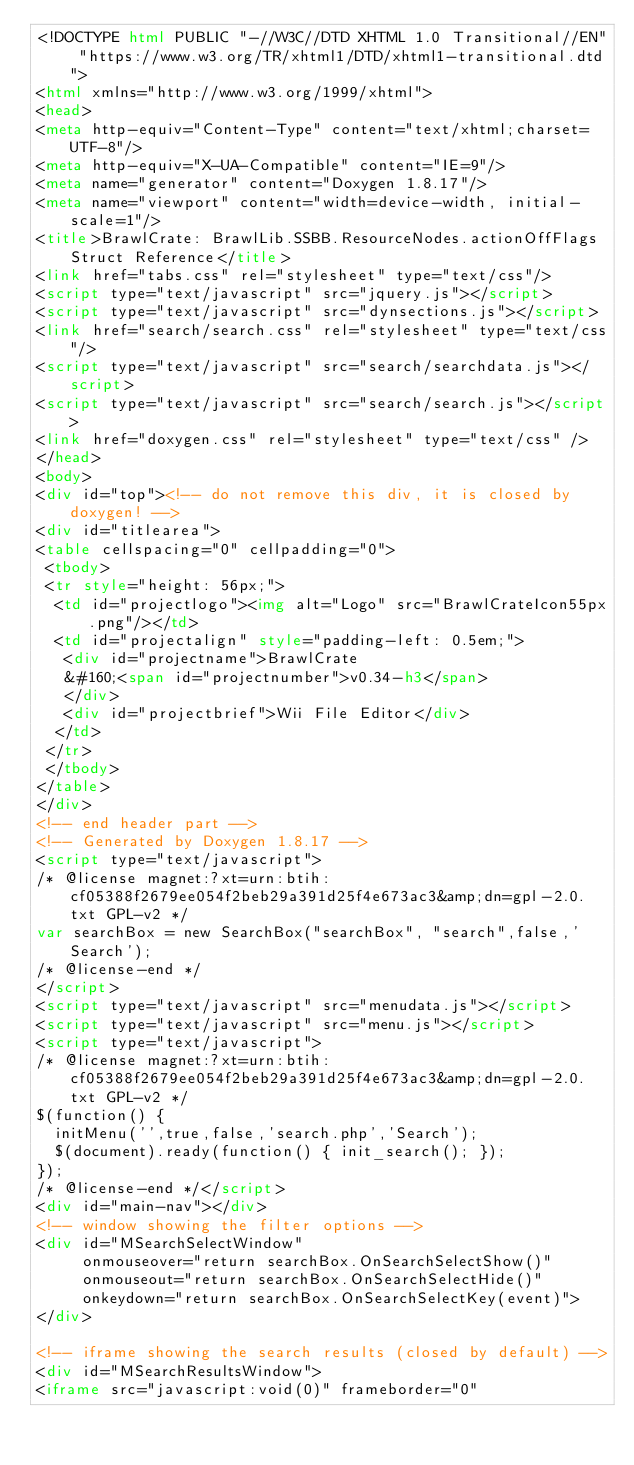Convert code to text. <code><loc_0><loc_0><loc_500><loc_500><_HTML_><!DOCTYPE html PUBLIC "-//W3C//DTD XHTML 1.0 Transitional//EN" "https://www.w3.org/TR/xhtml1/DTD/xhtml1-transitional.dtd">
<html xmlns="http://www.w3.org/1999/xhtml">
<head>
<meta http-equiv="Content-Type" content="text/xhtml;charset=UTF-8"/>
<meta http-equiv="X-UA-Compatible" content="IE=9"/>
<meta name="generator" content="Doxygen 1.8.17"/>
<meta name="viewport" content="width=device-width, initial-scale=1"/>
<title>BrawlCrate: BrawlLib.SSBB.ResourceNodes.actionOffFlags Struct Reference</title>
<link href="tabs.css" rel="stylesheet" type="text/css"/>
<script type="text/javascript" src="jquery.js"></script>
<script type="text/javascript" src="dynsections.js"></script>
<link href="search/search.css" rel="stylesheet" type="text/css"/>
<script type="text/javascript" src="search/searchdata.js"></script>
<script type="text/javascript" src="search/search.js"></script>
<link href="doxygen.css" rel="stylesheet" type="text/css" />
</head>
<body>
<div id="top"><!-- do not remove this div, it is closed by doxygen! -->
<div id="titlearea">
<table cellspacing="0" cellpadding="0">
 <tbody>
 <tr style="height: 56px;">
  <td id="projectlogo"><img alt="Logo" src="BrawlCrateIcon55px.png"/></td>
  <td id="projectalign" style="padding-left: 0.5em;">
   <div id="projectname">BrawlCrate
   &#160;<span id="projectnumber">v0.34-h3</span>
   </div>
   <div id="projectbrief">Wii File Editor</div>
  </td>
 </tr>
 </tbody>
</table>
</div>
<!-- end header part -->
<!-- Generated by Doxygen 1.8.17 -->
<script type="text/javascript">
/* @license magnet:?xt=urn:btih:cf05388f2679ee054f2beb29a391d25f4e673ac3&amp;dn=gpl-2.0.txt GPL-v2 */
var searchBox = new SearchBox("searchBox", "search",false,'Search');
/* @license-end */
</script>
<script type="text/javascript" src="menudata.js"></script>
<script type="text/javascript" src="menu.js"></script>
<script type="text/javascript">
/* @license magnet:?xt=urn:btih:cf05388f2679ee054f2beb29a391d25f4e673ac3&amp;dn=gpl-2.0.txt GPL-v2 */
$(function() {
  initMenu('',true,false,'search.php','Search');
  $(document).ready(function() { init_search(); });
});
/* @license-end */</script>
<div id="main-nav"></div>
<!-- window showing the filter options -->
<div id="MSearchSelectWindow"
     onmouseover="return searchBox.OnSearchSelectShow()"
     onmouseout="return searchBox.OnSearchSelectHide()"
     onkeydown="return searchBox.OnSearchSelectKey(event)">
</div>

<!-- iframe showing the search results (closed by default) -->
<div id="MSearchResultsWindow">
<iframe src="javascript:void(0)" frameborder="0" </code> 